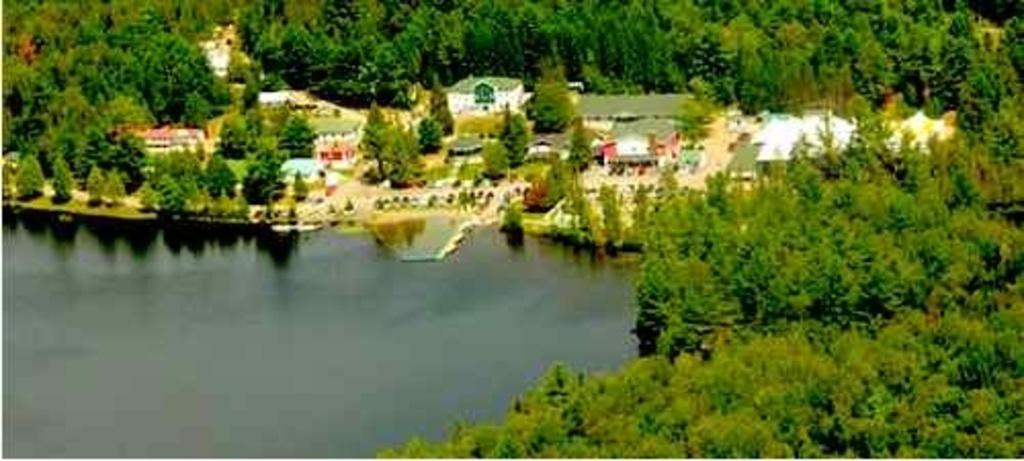What type of view is shown in the image? The image is an aerial view. What structures can be seen from this perspective? There are buildings visible in the image. What natural elements are present in the image? Trees and water are visible in the image. What man-made features can be seen in the image? There is a road in the image. What part of the buildings can be seen from this perspective? Roofs are visible in the image. What is the ground like in the image? The ground is visible in the image. What type of gold jewelry is being discussed by the committee in the image? There is no committee or gold jewelry present in the image; it is an aerial view of a landscape with buildings, trees, water, roads, roofs, and the ground. Can you describe the passionate kiss between the two individuals in the image? There are no individuals or kisses present in the image; it is an aerial view of a landscape with buildings, trees, water, roads, roofs, and the ground. 